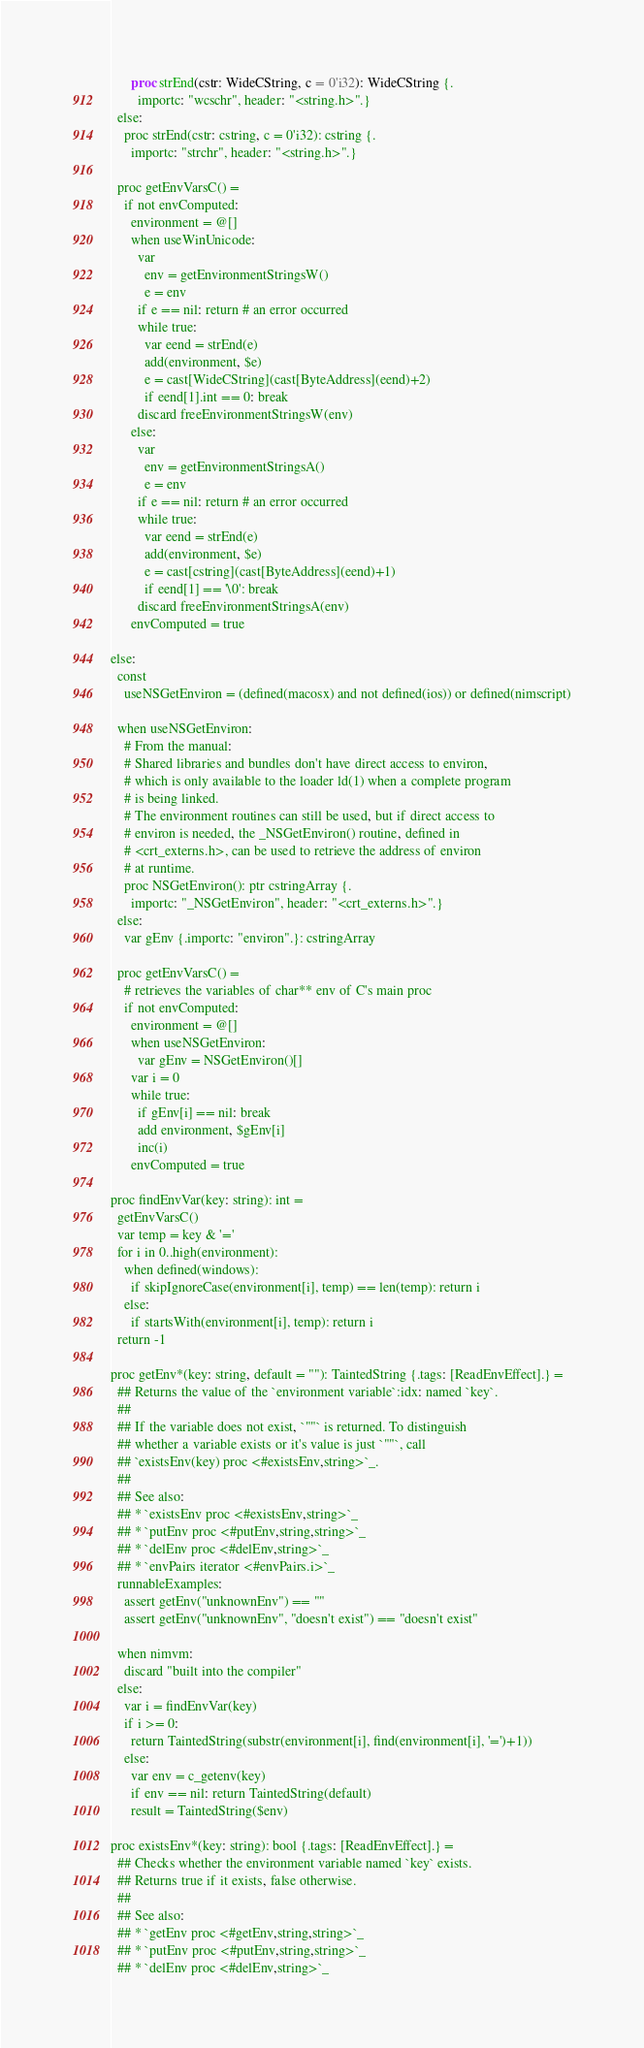<code> <loc_0><loc_0><loc_500><loc_500><_Nim_>      proc strEnd(cstr: WideCString, c = 0'i32): WideCString {.
        importc: "wcschr", header: "<string.h>".}
  else:
    proc strEnd(cstr: cstring, c = 0'i32): cstring {.
      importc: "strchr", header: "<string.h>".}

  proc getEnvVarsC() =
    if not envComputed:
      environment = @[]
      when useWinUnicode:
        var
          env = getEnvironmentStringsW()
          e = env
        if e == nil: return # an error occurred
        while true:
          var eend = strEnd(e)
          add(environment, $e)
          e = cast[WideCString](cast[ByteAddress](eend)+2)
          if eend[1].int == 0: break
        discard freeEnvironmentStringsW(env)
      else:
        var
          env = getEnvironmentStringsA()
          e = env
        if e == nil: return # an error occurred
        while true:
          var eend = strEnd(e)
          add(environment, $e)
          e = cast[cstring](cast[ByteAddress](eend)+1)
          if eend[1] == '\0': break
        discard freeEnvironmentStringsA(env)
      envComputed = true

else:
  const
    useNSGetEnviron = (defined(macosx) and not defined(ios)) or defined(nimscript)

  when useNSGetEnviron:
    # From the manual:
    # Shared libraries and bundles don't have direct access to environ,
    # which is only available to the loader ld(1) when a complete program
    # is being linked.
    # The environment routines can still be used, but if direct access to
    # environ is needed, the _NSGetEnviron() routine, defined in
    # <crt_externs.h>, can be used to retrieve the address of environ
    # at runtime.
    proc NSGetEnviron(): ptr cstringArray {.
      importc: "_NSGetEnviron", header: "<crt_externs.h>".}
  else:
    var gEnv {.importc: "environ".}: cstringArray

  proc getEnvVarsC() =
    # retrieves the variables of char** env of C's main proc
    if not envComputed:
      environment = @[]
      when useNSGetEnviron:
        var gEnv = NSGetEnviron()[]
      var i = 0
      while true:
        if gEnv[i] == nil: break
        add environment, $gEnv[i]
        inc(i)
      envComputed = true

proc findEnvVar(key: string): int =
  getEnvVarsC()
  var temp = key & '='
  for i in 0..high(environment):
    when defined(windows):
      if skipIgnoreCase(environment[i], temp) == len(temp): return i
    else:
      if startsWith(environment[i], temp): return i
  return -1

proc getEnv*(key: string, default = ""): TaintedString {.tags: [ReadEnvEffect].} =
  ## Returns the value of the `environment variable`:idx: named `key`.
  ##
  ## If the variable does not exist, `""` is returned. To distinguish
  ## whether a variable exists or it's value is just `""`, call
  ## `existsEnv(key) proc <#existsEnv,string>`_.
  ##
  ## See also:
  ## * `existsEnv proc <#existsEnv,string>`_
  ## * `putEnv proc <#putEnv,string,string>`_
  ## * `delEnv proc <#delEnv,string>`_
  ## * `envPairs iterator <#envPairs.i>`_
  runnableExamples:
    assert getEnv("unknownEnv") == ""
    assert getEnv("unknownEnv", "doesn't exist") == "doesn't exist"

  when nimvm:
    discard "built into the compiler"
  else:
    var i = findEnvVar(key)
    if i >= 0:
      return TaintedString(substr(environment[i], find(environment[i], '=')+1))
    else:
      var env = c_getenv(key)
      if env == nil: return TaintedString(default)
      result = TaintedString($env)

proc existsEnv*(key: string): bool {.tags: [ReadEnvEffect].} =
  ## Checks whether the environment variable named `key` exists.
  ## Returns true if it exists, false otherwise.
  ##
  ## See also:
  ## * `getEnv proc <#getEnv,string,string>`_
  ## * `putEnv proc <#putEnv,string,string>`_
  ## * `delEnv proc <#delEnv,string>`_</code> 